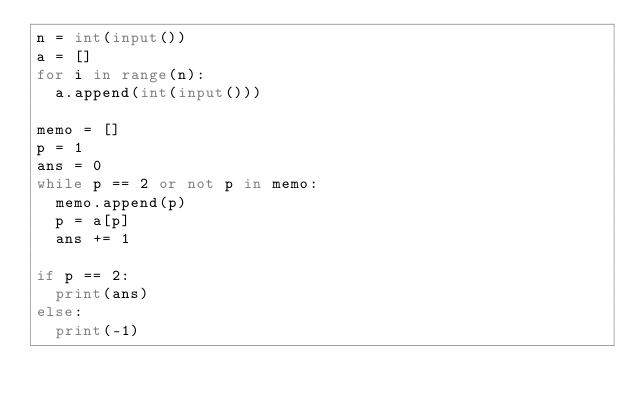<code> <loc_0><loc_0><loc_500><loc_500><_Python_>n = int(input())
a = []
for i in range(n):
  a.append(int(input()))

memo = []
p = 1
ans = 0
while p == 2 or not p in memo:
  memo.append(p)
  p = a[p]
  ans += 1
  
if p == 2:
  print(ans)
else:
  print(-1)</code> 